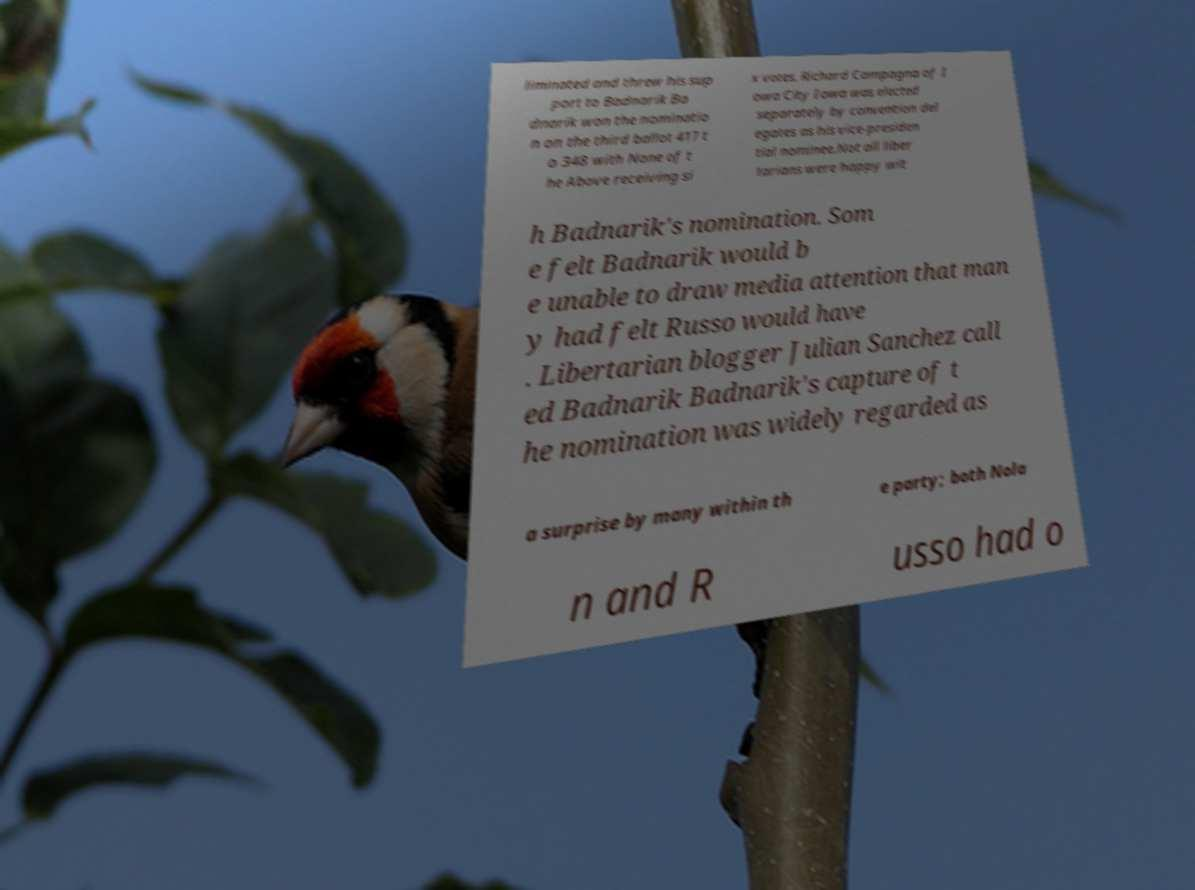I need the written content from this picture converted into text. Can you do that? liminated and threw his sup port to Badnarik Ba dnarik won the nominatio n on the third ballot 417 t o 348 with None of t he Above receiving si x votes. Richard Campagna of I owa City Iowa was elected separately by convention del egates as his vice-presiden tial nominee.Not all liber tarians were happy wit h Badnarik's nomination. Som e felt Badnarik would b e unable to draw media attention that man y had felt Russo would have . Libertarian blogger Julian Sanchez call ed Badnarik Badnarik's capture of t he nomination was widely regarded as a surprise by many within th e party; both Nola n and R usso had o 